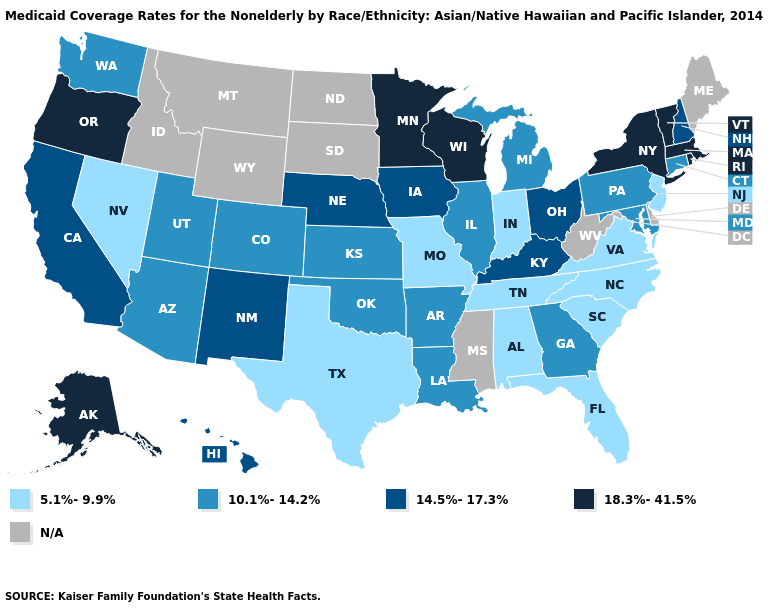Name the states that have a value in the range N/A?
Write a very short answer. Delaware, Idaho, Maine, Mississippi, Montana, North Dakota, South Dakota, West Virginia, Wyoming. What is the lowest value in the South?
Short answer required. 5.1%-9.9%. Does Massachusetts have the highest value in the USA?
Concise answer only. Yes. Is the legend a continuous bar?
Keep it brief. No. Does Virginia have the lowest value in the USA?
Quick response, please. Yes. Name the states that have a value in the range 14.5%-17.3%?
Concise answer only. California, Hawaii, Iowa, Kentucky, Nebraska, New Hampshire, New Mexico, Ohio. What is the lowest value in the West?
Be succinct. 5.1%-9.9%. How many symbols are there in the legend?
Be succinct. 5. Which states have the lowest value in the MidWest?
Answer briefly. Indiana, Missouri. What is the highest value in states that border Alabama?
Quick response, please. 10.1%-14.2%. Name the states that have a value in the range 5.1%-9.9%?
Keep it brief. Alabama, Florida, Indiana, Missouri, Nevada, New Jersey, North Carolina, South Carolina, Tennessee, Texas, Virginia. Name the states that have a value in the range N/A?
Keep it brief. Delaware, Idaho, Maine, Mississippi, Montana, North Dakota, South Dakota, West Virginia, Wyoming. What is the value of Alabama?
Write a very short answer. 5.1%-9.9%. What is the lowest value in states that border Maine?
Give a very brief answer. 14.5%-17.3%. What is the highest value in the USA?
Be succinct. 18.3%-41.5%. 